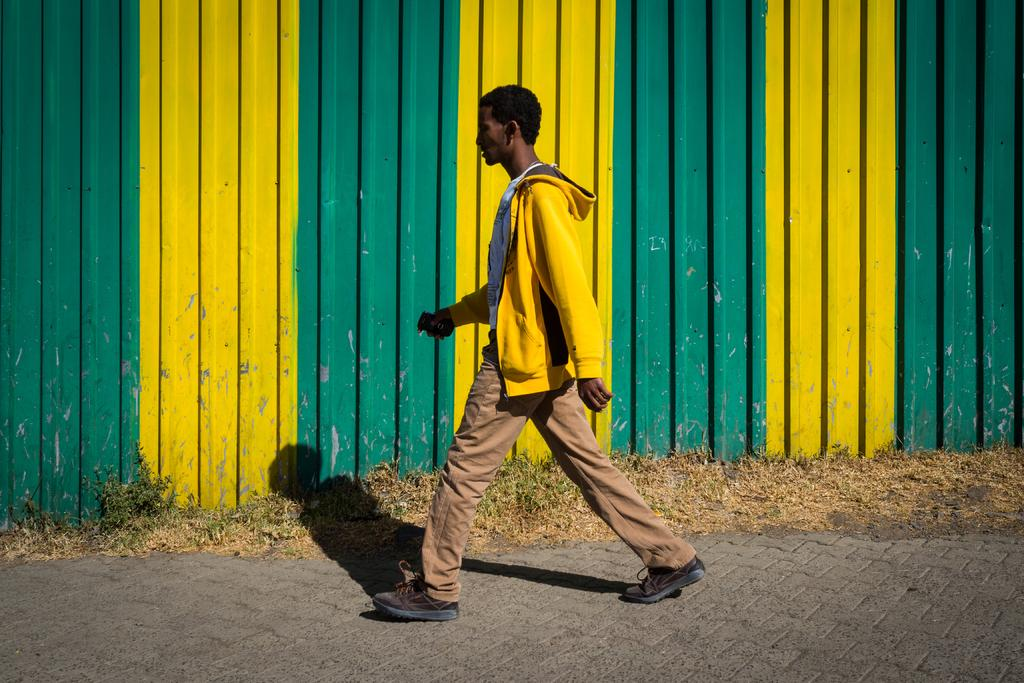What is the main subject of the image? There is a person walking on the road in the image. What can be seen on the ground in the image? Small plants are present on the ground. What is visible in the background of the image? There is a wall in the background of the image. What colors are present on the wall? The wall has yellow and green colors. What type of pancake is being served on the moon in the image? There is no moon or pancake present in the image. 